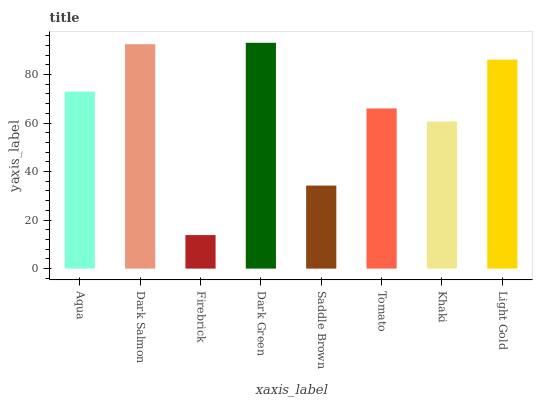Is Firebrick the minimum?
Answer yes or no. Yes. Is Dark Green the maximum?
Answer yes or no. Yes. Is Dark Salmon the minimum?
Answer yes or no. No. Is Dark Salmon the maximum?
Answer yes or no. No. Is Dark Salmon greater than Aqua?
Answer yes or no. Yes. Is Aqua less than Dark Salmon?
Answer yes or no. Yes. Is Aqua greater than Dark Salmon?
Answer yes or no. No. Is Dark Salmon less than Aqua?
Answer yes or no. No. Is Aqua the high median?
Answer yes or no. Yes. Is Tomato the low median?
Answer yes or no. Yes. Is Saddle Brown the high median?
Answer yes or no. No. Is Light Gold the low median?
Answer yes or no. No. 